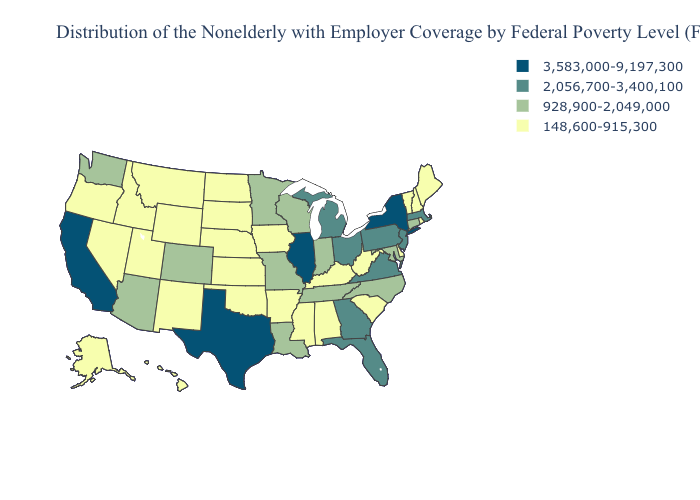What is the lowest value in the USA?
Concise answer only. 148,600-915,300. Name the states that have a value in the range 148,600-915,300?
Concise answer only. Alabama, Alaska, Arkansas, Delaware, Hawaii, Idaho, Iowa, Kansas, Kentucky, Maine, Mississippi, Montana, Nebraska, Nevada, New Hampshire, New Mexico, North Dakota, Oklahoma, Oregon, Rhode Island, South Carolina, South Dakota, Utah, Vermont, West Virginia, Wyoming. What is the lowest value in the South?
Short answer required. 148,600-915,300. What is the highest value in the MidWest ?
Keep it brief. 3,583,000-9,197,300. Which states hav the highest value in the Northeast?
Keep it brief. New York. What is the lowest value in the USA?
Be succinct. 148,600-915,300. Does the first symbol in the legend represent the smallest category?
Concise answer only. No. Which states have the lowest value in the Northeast?
Write a very short answer. Maine, New Hampshire, Rhode Island, Vermont. What is the lowest value in states that border Arkansas?
Concise answer only. 148,600-915,300. What is the value of Nevada?
Quick response, please. 148,600-915,300. What is the value of Texas?
Answer briefly. 3,583,000-9,197,300. Name the states that have a value in the range 928,900-2,049,000?
Keep it brief. Arizona, Colorado, Connecticut, Indiana, Louisiana, Maryland, Minnesota, Missouri, North Carolina, Tennessee, Washington, Wisconsin. Name the states that have a value in the range 928,900-2,049,000?
Write a very short answer. Arizona, Colorado, Connecticut, Indiana, Louisiana, Maryland, Minnesota, Missouri, North Carolina, Tennessee, Washington, Wisconsin. Name the states that have a value in the range 3,583,000-9,197,300?
Be succinct. California, Illinois, New York, Texas. Does the first symbol in the legend represent the smallest category?
Give a very brief answer. No. 